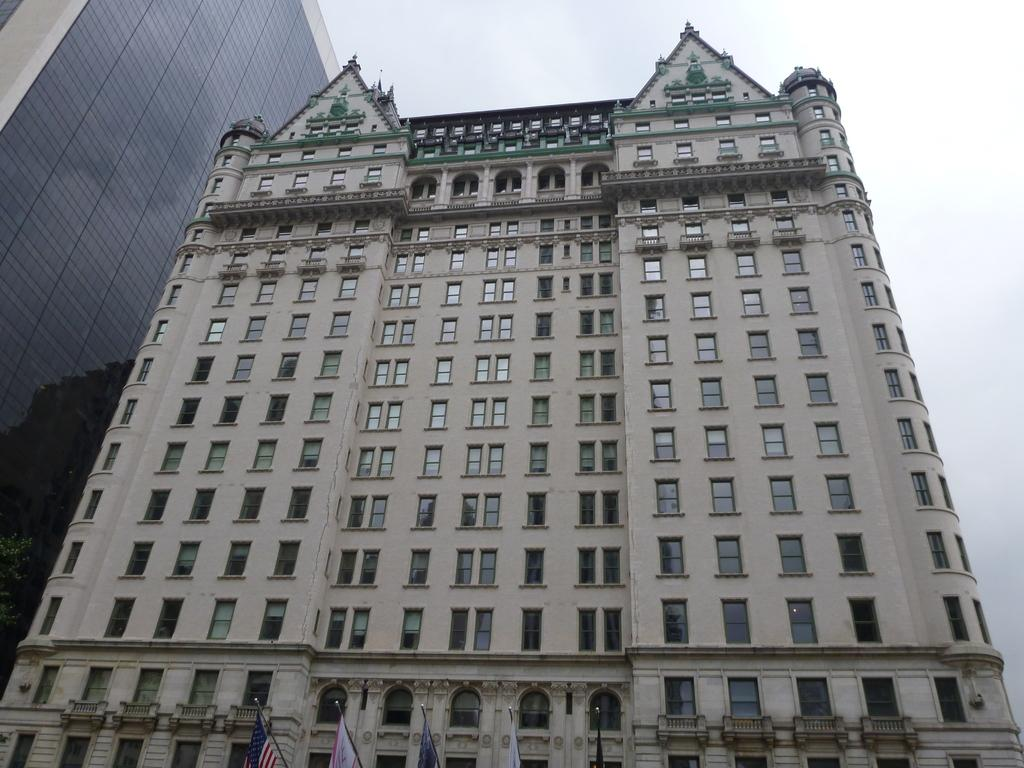What type of structures are present in the image? There are buildings in the image. What feature can be seen on the buildings? The buildings have windows. What additional objects are visible in the image? There are flags in the image. What can be seen in the background of the image? The sky is visible in the background of the image. What type of crown is worn by the person in the image? There is no person wearing a crown in the image; it features buildings, flags, and a visible sky. 